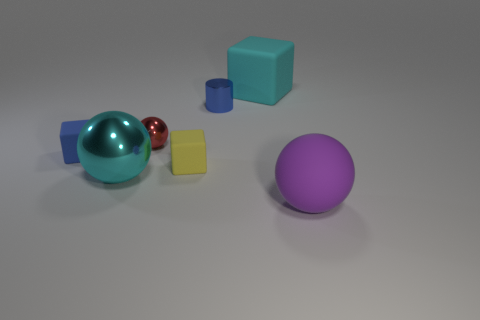Add 2 small red metallic cubes. How many objects exist? 9 Subtract all blocks. How many objects are left? 4 Subtract all tiny metallic objects. Subtract all large blue matte cubes. How many objects are left? 5 Add 1 metal objects. How many metal objects are left? 4 Add 3 small yellow rubber objects. How many small yellow rubber objects exist? 4 Subtract 0 purple cylinders. How many objects are left? 7 